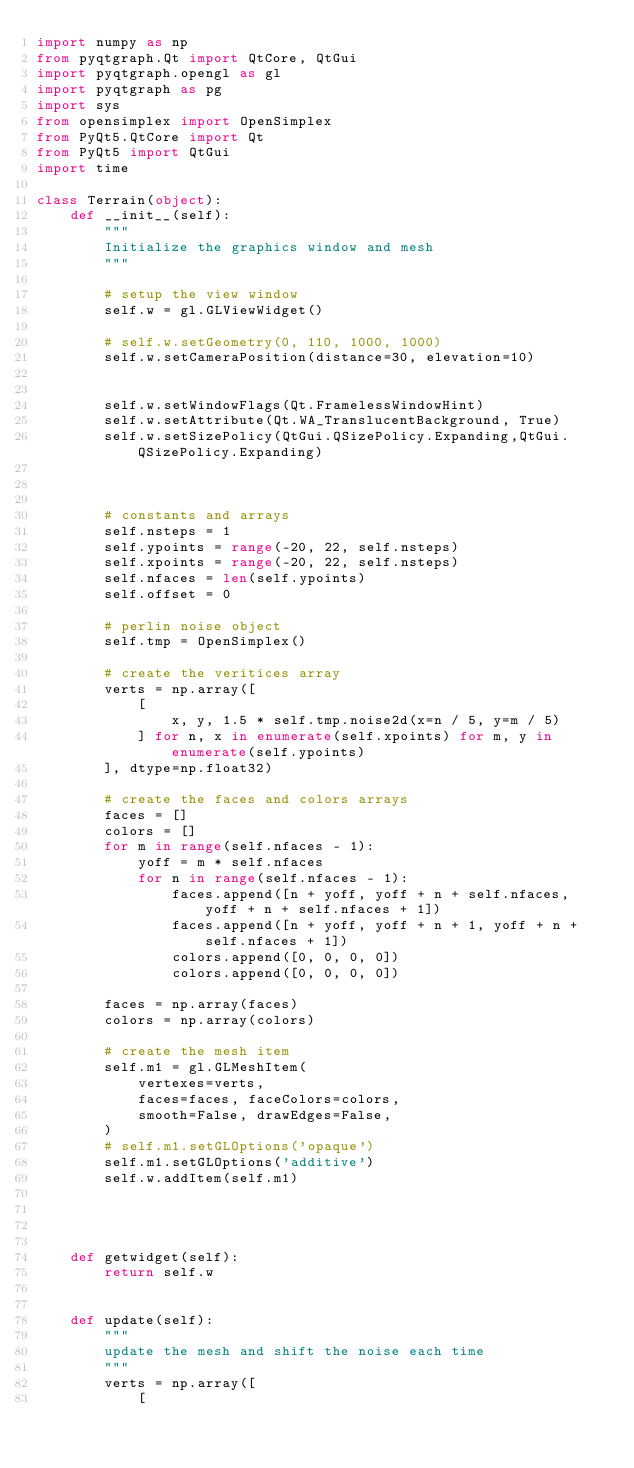<code> <loc_0><loc_0><loc_500><loc_500><_Python_>import numpy as np
from pyqtgraph.Qt import QtCore, QtGui
import pyqtgraph.opengl as gl
import pyqtgraph as pg
import sys
from opensimplex import OpenSimplex
from PyQt5.QtCore import Qt
from PyQt5 import QtGui
import time

class Terrain(object):
    def __init__(self):
        """
        Initialize the graphics window and mesh
        """

        # setup the view window
        self.w = gl.GLViewWidget()

        # self.w.setGeometry(0, 110, 1000, 1000)
        self.w.setCameraPosition(distance=30, elevation=10)


        self.w.setWindowFlags(Qt.FramelessWindowHint)
        self.w.setAttribute(Qt.WA_TranslucentBackground, True)
        self.w.setSizePolicy(QtGui.QSizePolicy.Expanding,QtGui.QSizePolicy.Expanding)



        # constants and arrays
        self.nsteps = 1
        self.ypoints = range(-20, 22, self.nsteps)
        self.xpoints = range(-20, 22, self.nsteps)
        self.nfaces = len(self.ypoints)
        self.offset = 0

        # perlin noise object
        self.tmp = OpenSimplex()

        # create the veritices array
        verts = np.array([
            [
                x, y, 1.5 * self.tmp.noise2d(x=n / 5, y=m / 5)
            ] for n, x in enumerate(self.xpoints) for m, y in enumerate(self.ypoints)
        ], dtype=np.float32)

        # create the faces and colors arrays
        faces = []
        colors = []
        for m in range(self.nfaces - 1):
            yoff = m * self.nfaces
            for n in range(self.nfaces - 1):
                faces.append([n + yoff, yoff + n + self.nfaces, yoff + n + self.nfaces + 1])
                faces.append([n + yoff, yoff + n + 1, yoff + n + self.nfaces + 1])
                colors.append([0, 0, 0, 0])
                colors.append([0, 0, 0, 0])

        faces = np.array(faces)
        colors = np.array(colors)

        # create the mesh item
        self.m1 = gl.GLMeshItem(
            vertexes=verts,
            faces=faces, faceColors=colors,
            smooth=False, drawEdges=False,
        )
        # self.m1.setGLOptions('opaque')
        self.m1.setGLOptions('additive')
        self.w.addItem(self.m1)




    def getwidget(self):
        return self.w


    def update(self):
        """
        update the mesh and shift the noise each time
        """
        verts = np.array([
            [</code> 